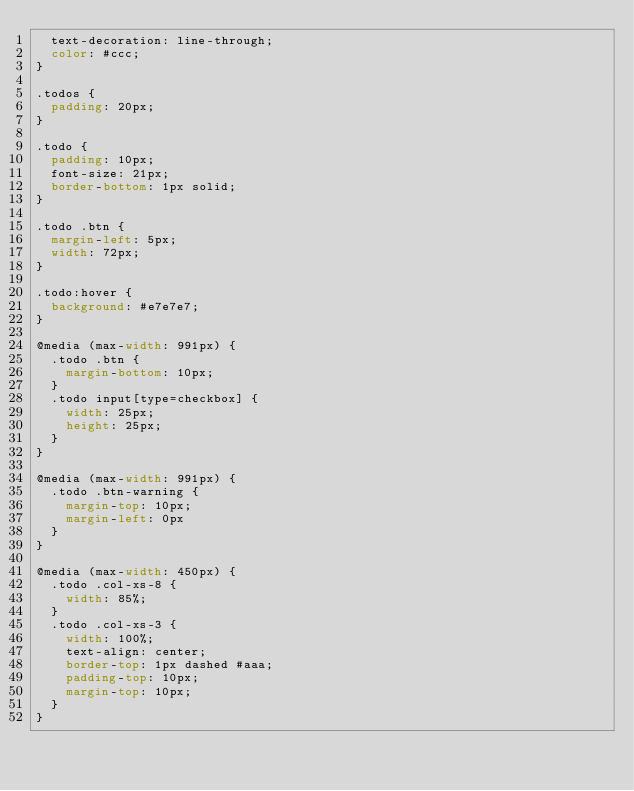Convert code to text. <code><loc_0><loc_0><loc_500><loc_500><_CSS_>  text-decoration: line-through;
  color: #ccc;
}

.todos {
  padding: 20px;
}

.todo {
  padding: 10px;
  font-size: 21px;
  border-bottom: 1px solid;
}

.todo .btn {
  margin-left: 5px;
  width: 72px;
}

.todo:hover {
  background: #e7e7e7;
}

@media (max-width: 991px) {
  .todo .btn {
    margin-bottom: 10px;
  }
  .todo input[type=checkbox] {
    width: 25px;
    height: 25px;
  }
}

@media (max-width: 991px) {
  .todo .btn-warning {
    margin-top: 10px;
    margin-left: 0px
  }
}

@media (max-width: 450px) {
  .todo .col-xs-8 {
    width: 85%;
  }
  .todo .col-xs-3 {
    width: 100%;
    text-align: center;
    border-top: 1px dashed #aaa;
    padding-top: 10px;
    margin-top: 10px;
  }
}
</code> 